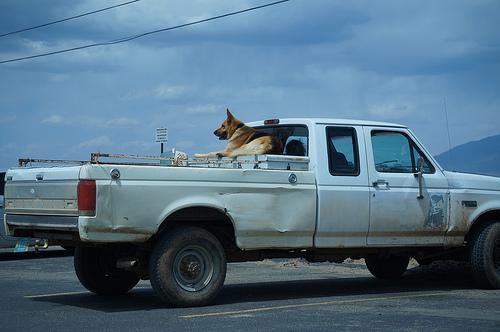How many animals are there?
Give a very brief answer. 1. 